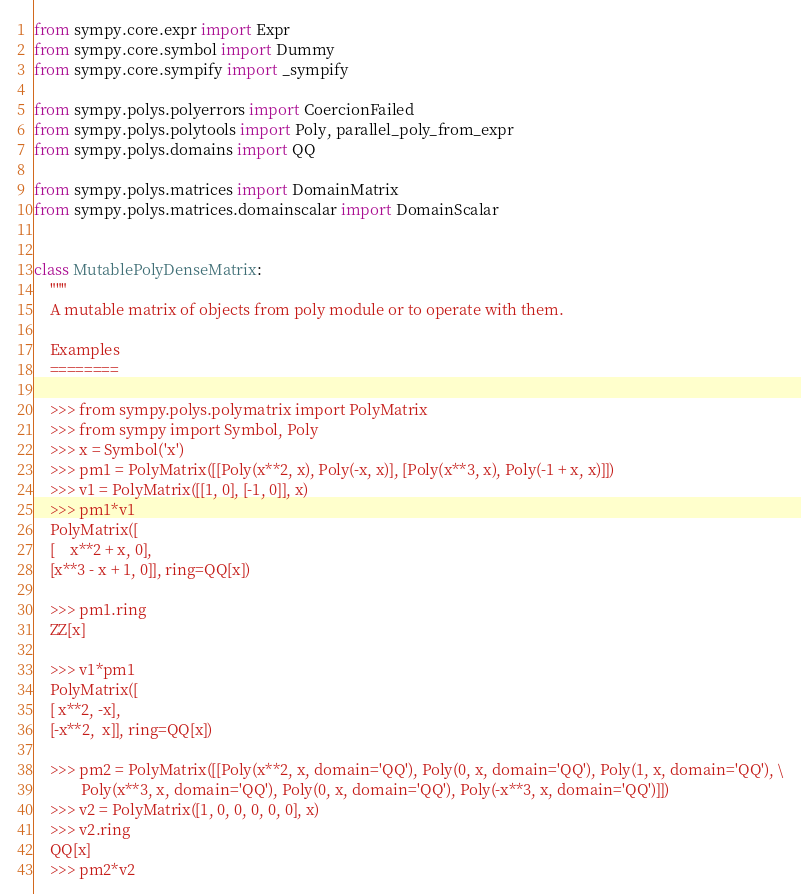<code> <loc_0><loc_0><loc_500><loc_500><_Python_>from sympy.core.expr import Expr
from sympy.core.symbol import Dummy
from sympy.core.sympify import _sympify

from sympy.polys.polyerrors import CoercionFailed
from sympy.polys.polytools import Poly, parallel_poly_from_expr
from sympy.polys.domains import QQ

from sympy.polys.matrices import DomainMatrix
from sympy.polys.matrices.domainscalar import DomainScalar


class MutablePolyDenseMatrix:
    """
    A mutable matrix of objects from poly module or to operate with them.

    Examples
    ========

    >>> from sympy.polys.polymatrix import PolyMatrix
    >>> from sympy import Symbol, Poly
    >>> x = Symbol('x')
    >>> pm1 = PolyMatrix([[Poly(x**2, x), Poly(-x, x)], [Poly(x**3, x), Poly(-1 + x, x)]])
    >>> v1 = PolyMatrix([[1, 0], [-1, 0]], x)
    >>> pm1*v1
    PolyMatrix([
    [    x**2 + x, 0],
    [x**3 - x + 1, 0]], ring=QQ[x])

    >>> pm1.ring
    ZZ[x]

    >>> v1*pm1
    PolyMatrix([
    [ x**2, -x],
    [-x**2,  x]], ring=QQ[x])

    >>> pm2 = PolyMatrix([[Poly(x**2, x, domain='QQ'), Poly(0, x, domain='QQ'), Poly(1, x, domain='QQ'), \
            Poly(x**3, x, domain='QQ'), Poly(0, x, domain='QQ'), Poly(-x**3, x, domain='QQ')]])
    >>> v2 = PolyMatrix([1, 0, 0, 0, 0, 0], x)
    >>> v2.ring
    QQ[x]
    >>> pm2*v2</code> 